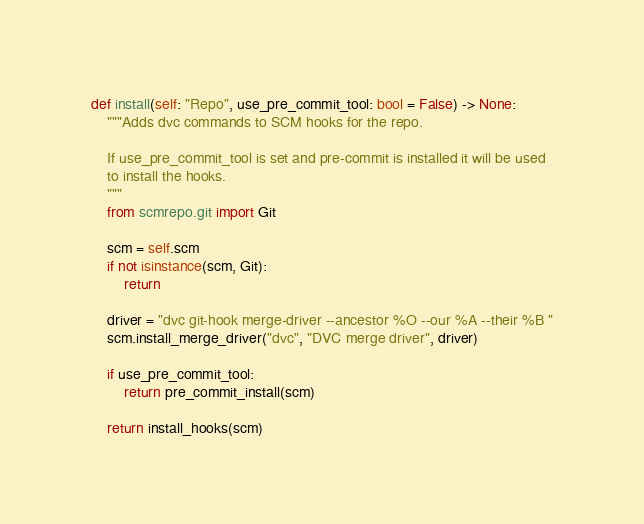Convert code to text. <code><loc_0><loc_0><loc_500><loc_500><_Python_>

def install(self: "Repo", use_pre_commit_tool: bool = False) -> None:
    """Adds dvc commands to SCM hooks for the repo.

    If use_pre_commit_tool is set and pre-commit is installed it will be used
    to install the hooks.
    """
    from scmrepo.git import Git

    scm = self.scm
    if not isinstance(scm, Git):
        return

    driver = "dvc git-hook merge-driver --ancestor %O --our %A --their %B "
    scm.install_merge_driver("dvc", "DVC merge driver", driver)

    if use_pre_commit_tool:
        return pre_commit_install(scm)

    return install_hooks(scm)
</code> 